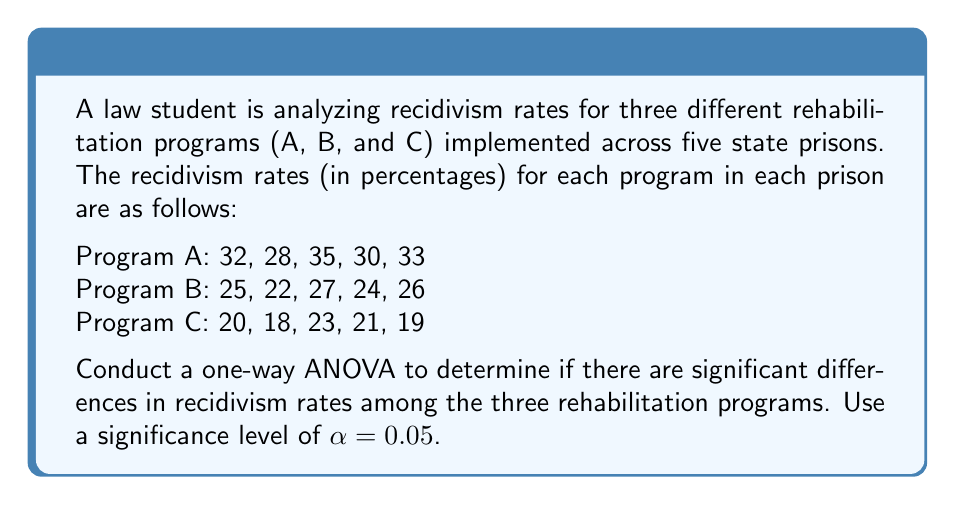Can you answer this question? To conduct a one-way ANOVA, we'll follow these steps:

1. Calculate the sum of squares between groups (SSB)
2. Calculate the sum of squares within groups (SSW)
3. Calculate the total sum of squares (SST)
4. Compute degrees of freedom (df)
5. Calculate mean squares
6. Compute the F-statistic
7. Determine the critical F-value
8. Make a decision based on the F-statistic and critical F-value

Step 1: Calculate SSB

First, we need to find the grand mean and group means:

Grand mean: $\bar{X} = \frac{32+28+35+30+33+25+22+27+24+26+20+18+23+21+19}{15} = 25.53$

Group means:
$\bar{X}_A = 31.6$
$\bar{X}_B = 24.8$
$\bar{X}_C = 20.2$

Now, we can calculate SSB:

$$SSB = n\sum_{i=1}^k(\bar{X}_i - \bar{X})^2$$

Where $n$ is the number of observations per group (5) and $k$ is the number of groups (3).

$$SSB = 5[(31.6 - 25.53)^2 + (24.8 - 25.53)^2 + (20.2 - 25.53)^2] = 422.13$$

Step 2: Calculate SSW

$$SSW = \sum_{i=1}^k\sum_{j=1}^n(X_{ij} - \bar{X}_i)^2$$

For Program A: $(32-31.6)^2 + (28-31.6)^2 + (35-31.6)^2 + (30-31.6)^2 + (33-31.6)^2 = 36.8$
For Program B: $(25-24.8)^2 + (22-24.8)^2 + (27-24.8)^2 + (24-24.8)^2 + (26-24.8)^2 = 14.8$
For Program C: $(20-20.2)^2 + (18-20.2)^2 + (23-20.2)^2 + (21-20.2)^2 + (19-20.2)^2 = 16.8$

$$SSW = 36.8 + 14.8 + 16.8 = 68.4$$

Step 3: Calculate SST

$$SST = SSB + SSW = 422.13 + 68.4 = 490.53$$

Step 4: Compute degrees of freedom

df between groups = $k - 1 = 3 - 1 = 2$
df within groups = $N - k = 15 - 3 = 12$
df total = $N - 1 = 15 - 1 = 14$

Step 5: Calculate mean squares

$$MSB = \frac{SSB}{df_{between}} = \frac{422.13}{2} = 211.065$$
$$MSW = \frac{SSW}{df_{within}} = \frac{68.4}{12} = 5.7$$

Step 6: Compute the F-statistic

$$F = \frac{MSB}{MSW} = \frac{211.065}{5.7} = 37.03$$

Step 7: Determine the critical F-value

For $\alpha = 0.05$, $df_{between} = 2$, and $df_{within} = 12$, the critical F-value is approximately 3.89.

Step 8: Make a decision

Since the calculated F-statistic (37.03) is greater than the critical F-value (3.89), we reject the null hypothesis.
Answer: The one-way ANOVA results show a statistically significant difference in recidivism rates among the three rehabilitation programs (F(2, 12) = 37.03, p < 0.05). This suggests that at least one of the rehabilitation programs has a significantly different effect on recidivism rates compared to the others. 